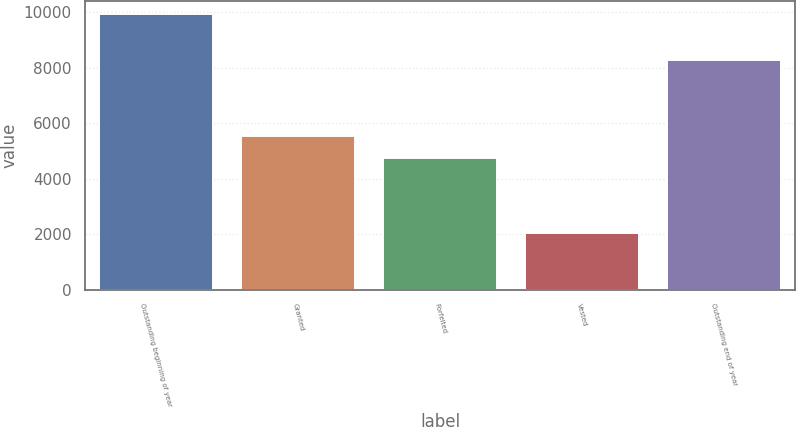Convert chart. <chart><loc_0><loc_0><loc_500><loc_500><bar_chart><fcel>Outstanding beginning of year<fcel>Granted<fcel>Forfeited<fcel>Vested<fcel>Outstanding end of year<nl><fcel>9923<fcel>5531.4<fcel>4745<fcel>2059<fcel>8284<nl></chart> 